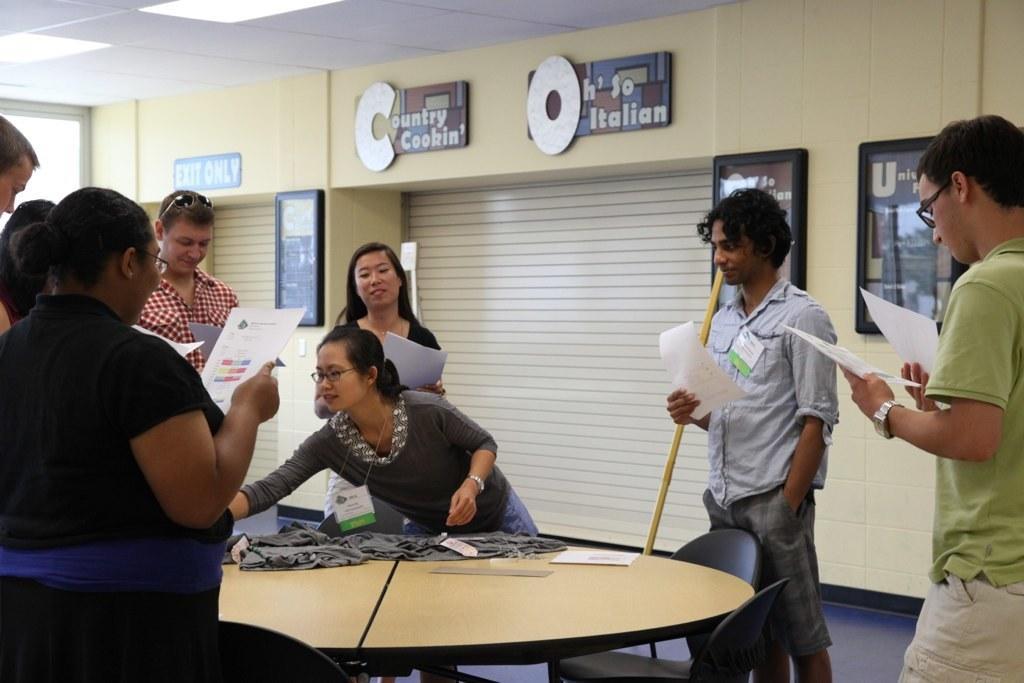Please provide a concise description of this image. In this image I can see there are group of people who are standing beside a table by holding a piece of paper in their hands. Behind this people we have a shutter and a few photos on the wall. 